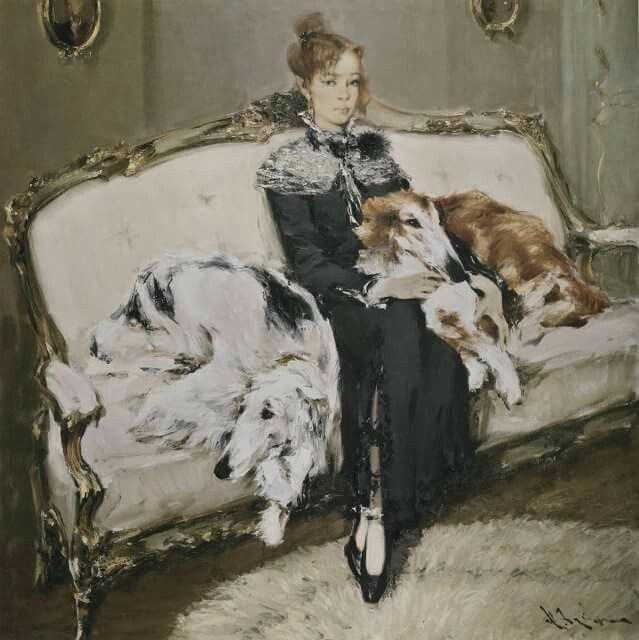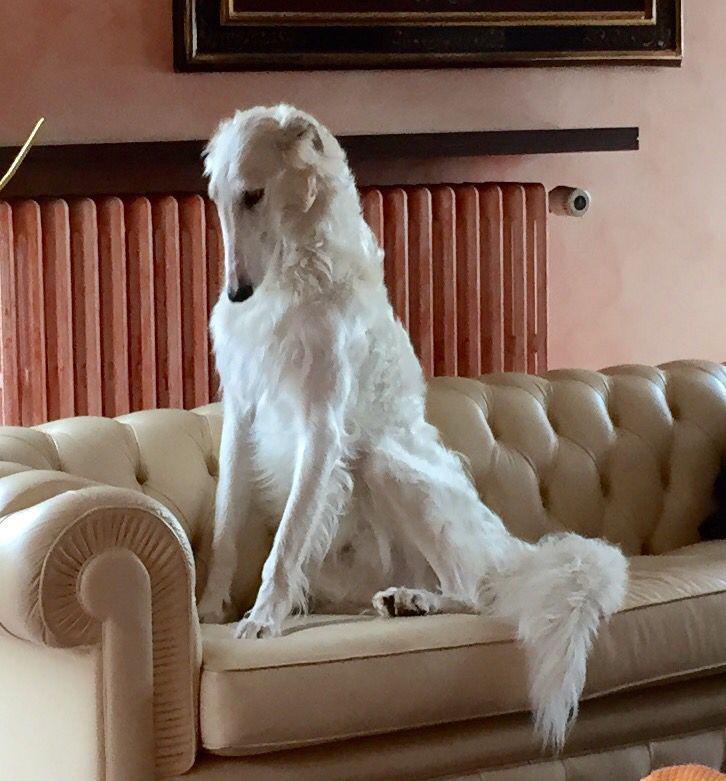The first image is the image on the left, the second image is the image on the right. Considering the images on both sides, is "There are three dogs in the image pair." valid? Answer yes or no. Yes. The first image is the image on the left, the second image is the image on the right. For the images shown, is this caption "A lady wearing a long dress is with her dogs in at least one of the images." true? Answer yes or no. Yes. 